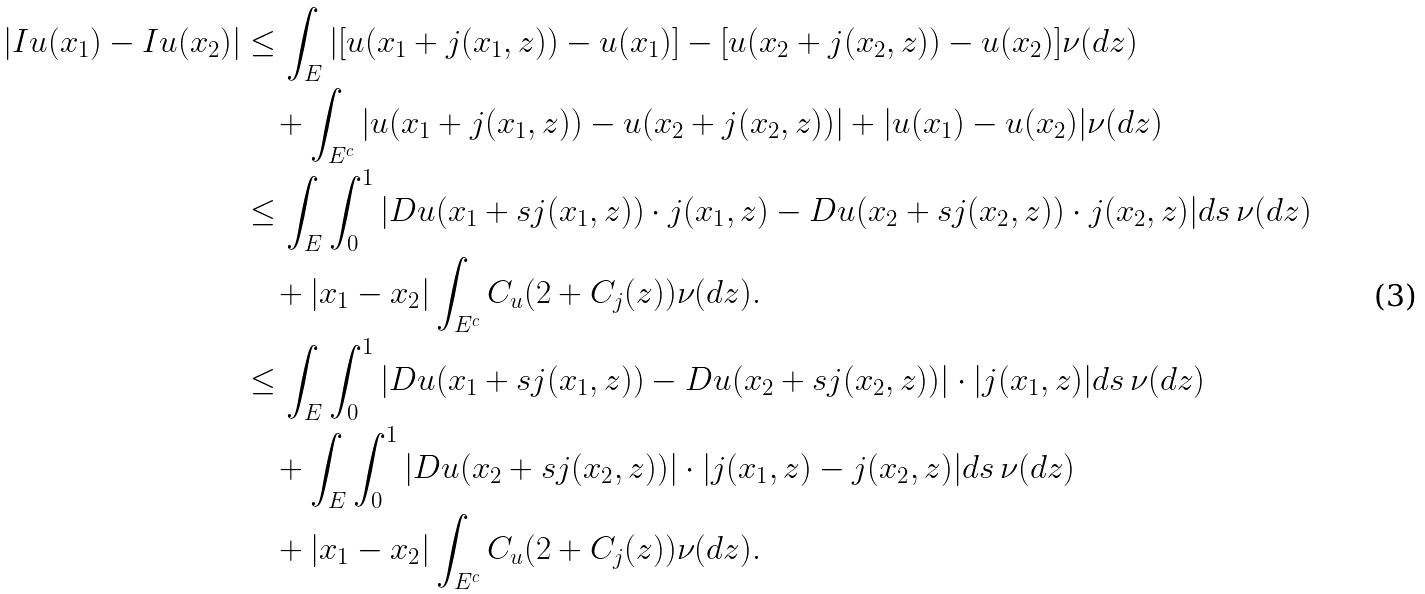<formula> <loc_0><loc_0><loc_500><loc_500>| I u ( x _ { 1 } ) - I u ( x _ { 2 } ) | & \leq \int _ { E } | [ u ( x _ { 1 } + j ( x _ { 1 } , z ) ) - u ( x _ { 1 } ) ] - [ u ( x _ { 2 } + j ( x _ { 2 } , z ) ) - u ( x _ { 2 } ) ] \nu ( d z ) \\ & \quad + \int _ { E ^ { c } } | u ( x _ { 1 } + j ( x _ { 1 } , z ) ) - u ( x _ { 2 } + j ( x _ { 2 } , z ) ) | + | u ( x _ { 1 } ) - u ( x _ { 2 } ) | \nu ( d z ) \\ & \leq \int _ { E } \int _ { 0 } ^ { 1 } | D u ( x _ { 1 } + s j ( x _ { 1 } , z ) ) \cdot j ( x _ { 1 } , z ) - D u ( x _ { 2 } + s j ( x _ { 2 } , z ) ) \cdot j ( x _ { 2 } , z ) | d s \, \nu ( d z ) \\ & \quad + | x _ { 1 } - x _ { 2 } | \int _ { E ^ { c } } C _ { u } ( 2 + C _ { j } ( z ) ) \nu ( d z ) . \\ & \leq \int _ { E } \int _ { 0 } ^ { 1 } | D u ( x _ { 1 } + s j ( x _ { 1 } , z ) ) - D u ( x _ { 2 } + s j ( x _ { 2 } , z ) ) | \cdot | j ( x _ { 1 } , z ) | d s \, \nu ( d z ) \\ & \quad + \int _ { E } \int _ { 0 } ^ { 1 } | D u ( x _ { 2 } + s j ( x _ { 2 } , z ) ) | \cdot | j ( x _ { 1 } , z ) - j ( x _ { 2 } , z ) | d s \, \nu ( d z ) \\ & \quad + | x _ { 1 } - x _ { 2 } | \int _ { E ^ { c } } C _ { u } ( 2 + C _ { j } ( z ) ) \nu ( d z ) .</formula> 